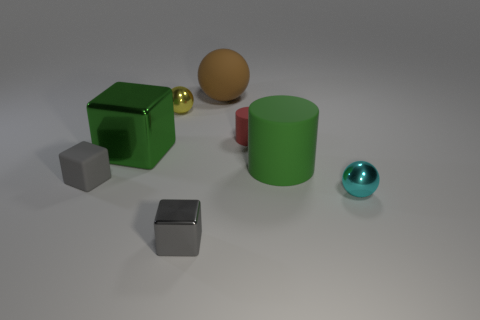Are there any other things that have the same shape as the brown rubber object?
Provide a short and direct response. Yes. Is the number of metal cubes that are right of the tiny red matte object greater than the number of big yellow metallic spheres?
Ensure brevity in your answer.  No. There is a small yellow shiny object; are there any large matte cylinders on the left side of it?
Your answer should be compact. No. Is the cyan object the same size as the green cube?
Your answer should be very brief. No. What size is the yellow metal thing that is the same shape as the big brown matte object?
Keep it short and to the point. Small. What material is the cube that is behind the large green object to the right of the small red thing?
Provide a short and direct response. Metal. Do the large brown object and the tiny red thing have the same shape?
Offer a very short reply. No. How many small objects are left of the big brown rubber sphere and to the right of the green metallic cube?
Offer a terse response. 2. Is the number of large matte objects that are behind the big ball the same as the number of tiny gray objects that are in front of the small cyan metallic thing?
Your answer should be very brief. No. There is a metallic object to the right of the brown thing; is it the same size as the metallic block behind the cyan object?
Your answer should be very brief. No. 